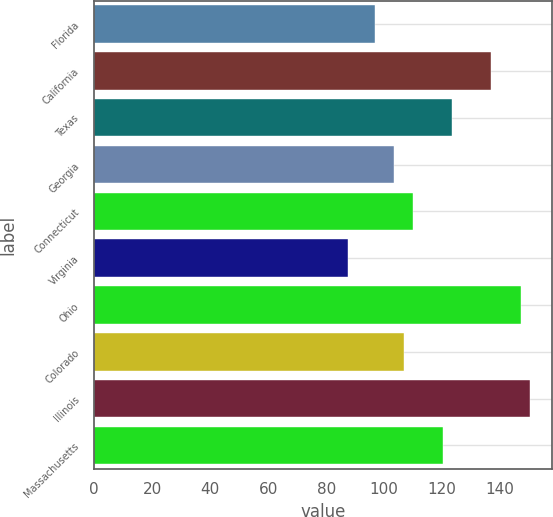Convert chart to OTSL. <chart><loc_0><loc_0><loc_500><loc_500><bar_chart><fcel>Florida<fcel>California<fcel>Texas<fcel>Georgia<fcel>Connecticut<fcel>Virginia<fcel>Ohio<fcel>Colorado<fcel>Illinois<fcel>Massachusetts<nl><fcel>96.66<fcel>136.98<fcel>123.54<fcel>103.38<fcel>110.1<fcel>87.5<fcel>147.06<fcel>106.74<fcel>150.42<fcel>120.18<nl></chart> 